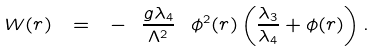<formula> <loc_0><loc_0><loc_500><loc_500>W ( r ) \ = \ - \ \frac { g \lambda _ { 4 } } { \Lambda ^ { 2 } } \ \phi ^ { 2 } ( r ) \left ( \frac { \lambda _ { 3 } } { \lambda _ { 4 } } + \phi ( r ) \right ) .</formula> 